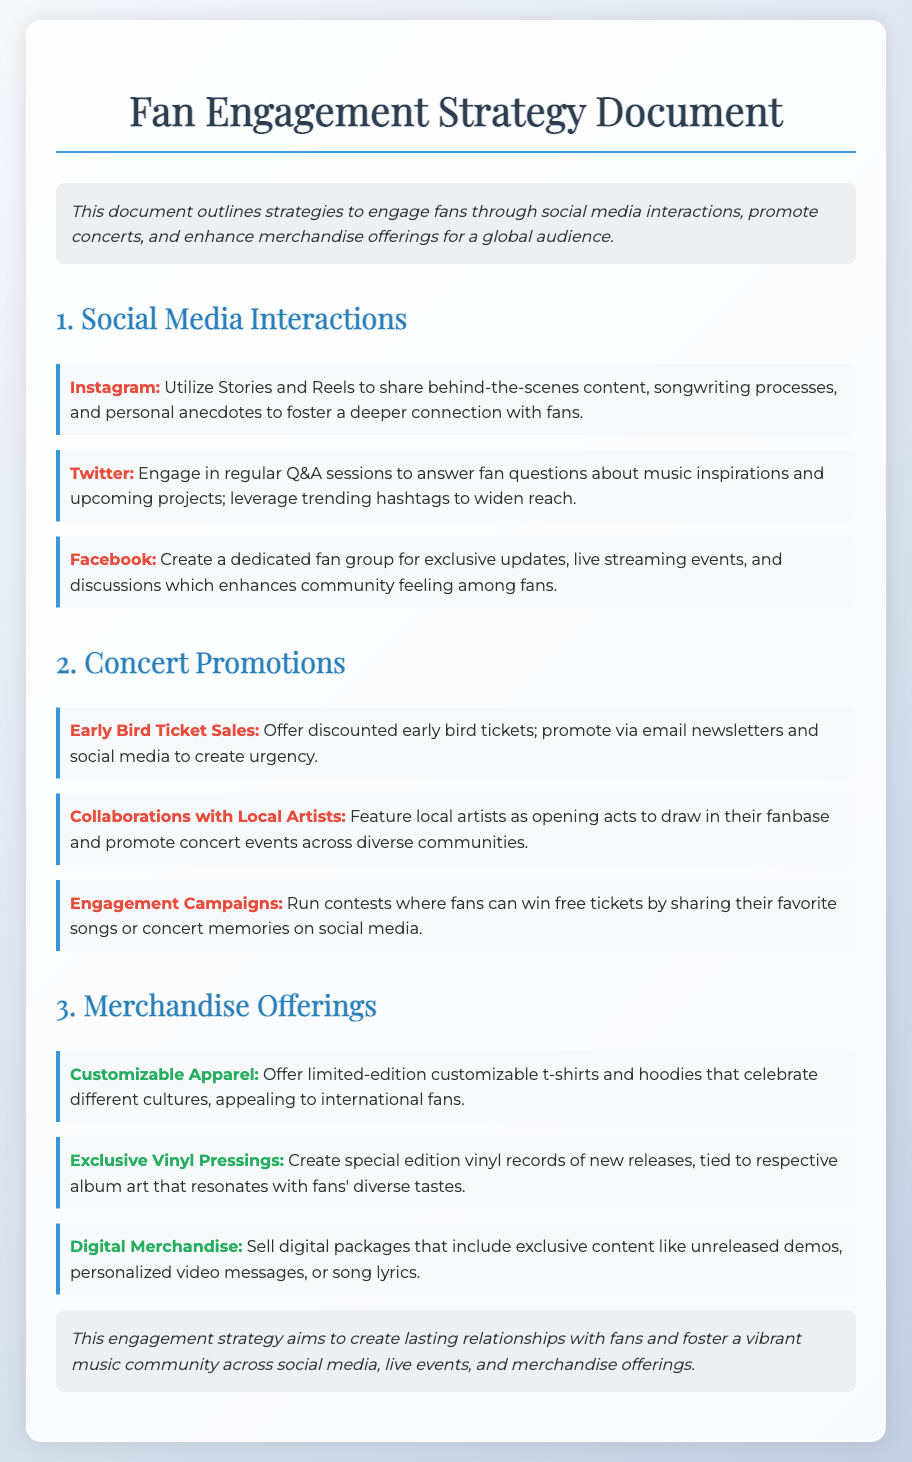What is the main purpose of the document? The document outlines strategies for engaging fans through social media, concert promotions, and merchandise offerings.
Answer: Engagement strategies How many platforms are mentioned under social media interactions? The document lists three platforms for social media interactions: Instagram, Twitter, and Facebook.
Answer: Three What type of ticket sales are suggested for concert promotions? The document suggests offering discounted early bird ticket sales to create urgency.
Answer: Early Bird Ticket Sales What item is proposed for enhancing merchandise offerings that is related to culture? The document mentions offering customizable t-shirts and hoodies that celebrate different cultures.
Answer: Customizable Apparel Which engagement activity involves sharing content on social media? The document refers to running contests where fans can win free tickets by sharing their favorite songs or concert memories.
Answer: Engagement Campaigns What is the suggested promotional strategy for concert events? The document highlights collaborations with local artists as a way to draw in their fanbase.
Answer: Collaborations with Local Artists What kind of exclusive merchandise is mentioned related to music? The document includes creating special edition vinyl records of new releases as exclusive merchandise.
Answer: Exclusive Vinyl Pressings What type of digital product is recommended in the merchandise offerings? The document suggests selling digital packages that include exclusive content like unreleased demos.
Answer: Digital Merchandise What format of interaction is proposed for Twitter? The document suggests engaging in regular Q&A sessions to answer fan questions.
Answer: Q&A sessions 